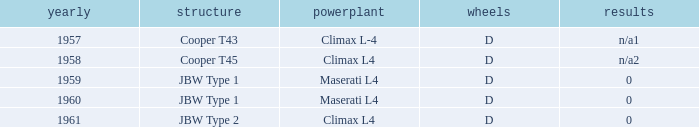What is the tyres with a year earlier than 1961 for a climax l4 engine? D. 